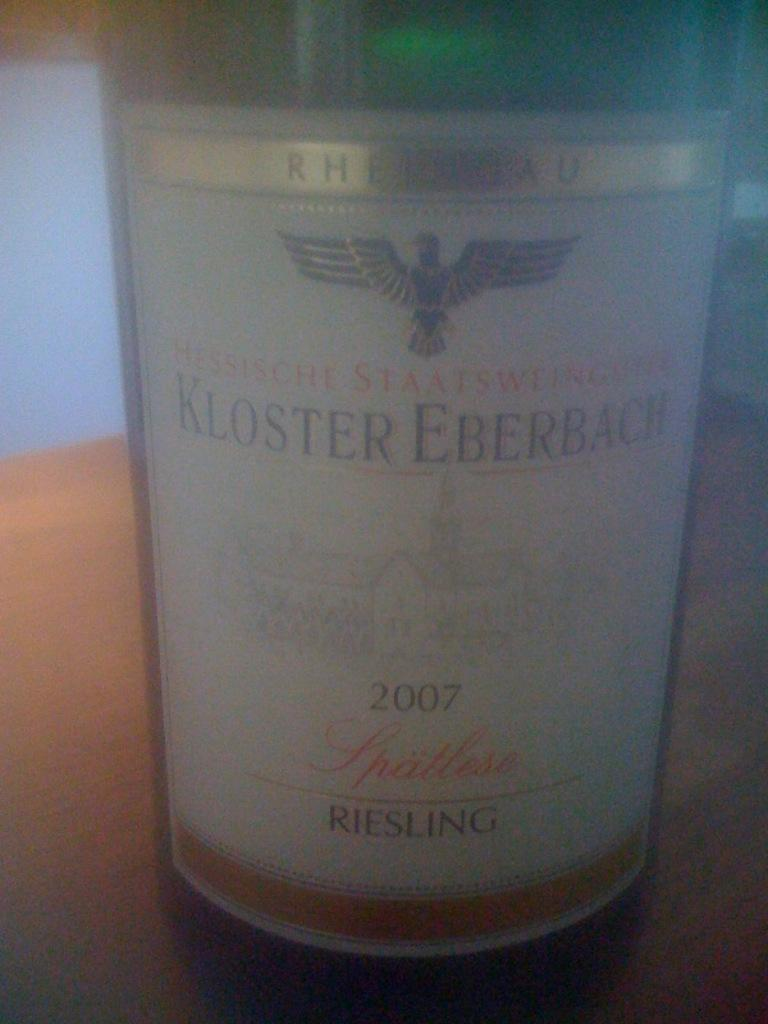<image>
Present a compact description of the photo's key features. Bottle of Kloster Eberbach 2007 Riesling bottle up close picture 